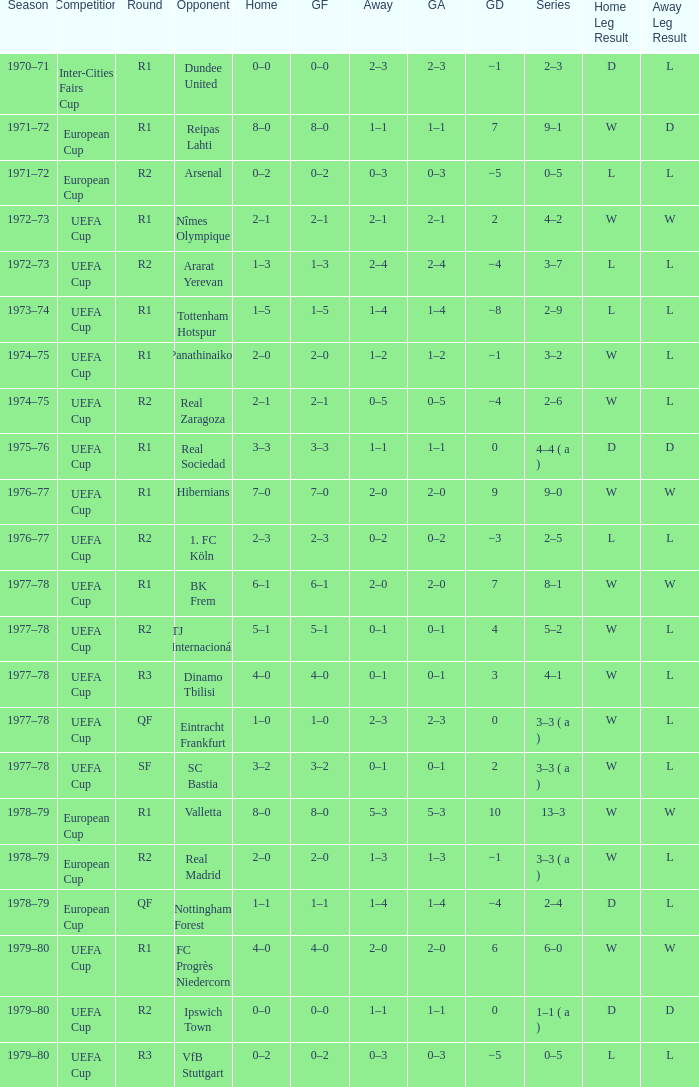Which Home has a Competition of european cup, and a Round of qf? 1–1. 